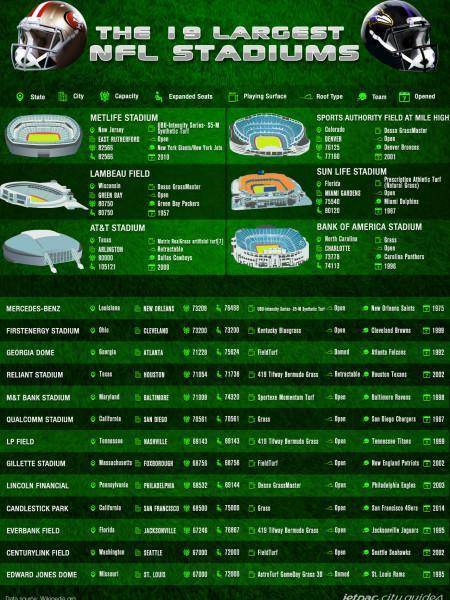Which stadium is shown in the 3rd picture?
Answer the question with a short phrase. Lambeau field How many stadium names are listed without pictures? 13 What is the name of the stadium shown in the second picture? sports authority field at mile high Which is the stadium shown in the 6th picture? Bank of America stadium Which is the stadium mentioned in the second last row of the list? CenturyLink Field How many pictures of stadiums are shown in this infographic? 6 